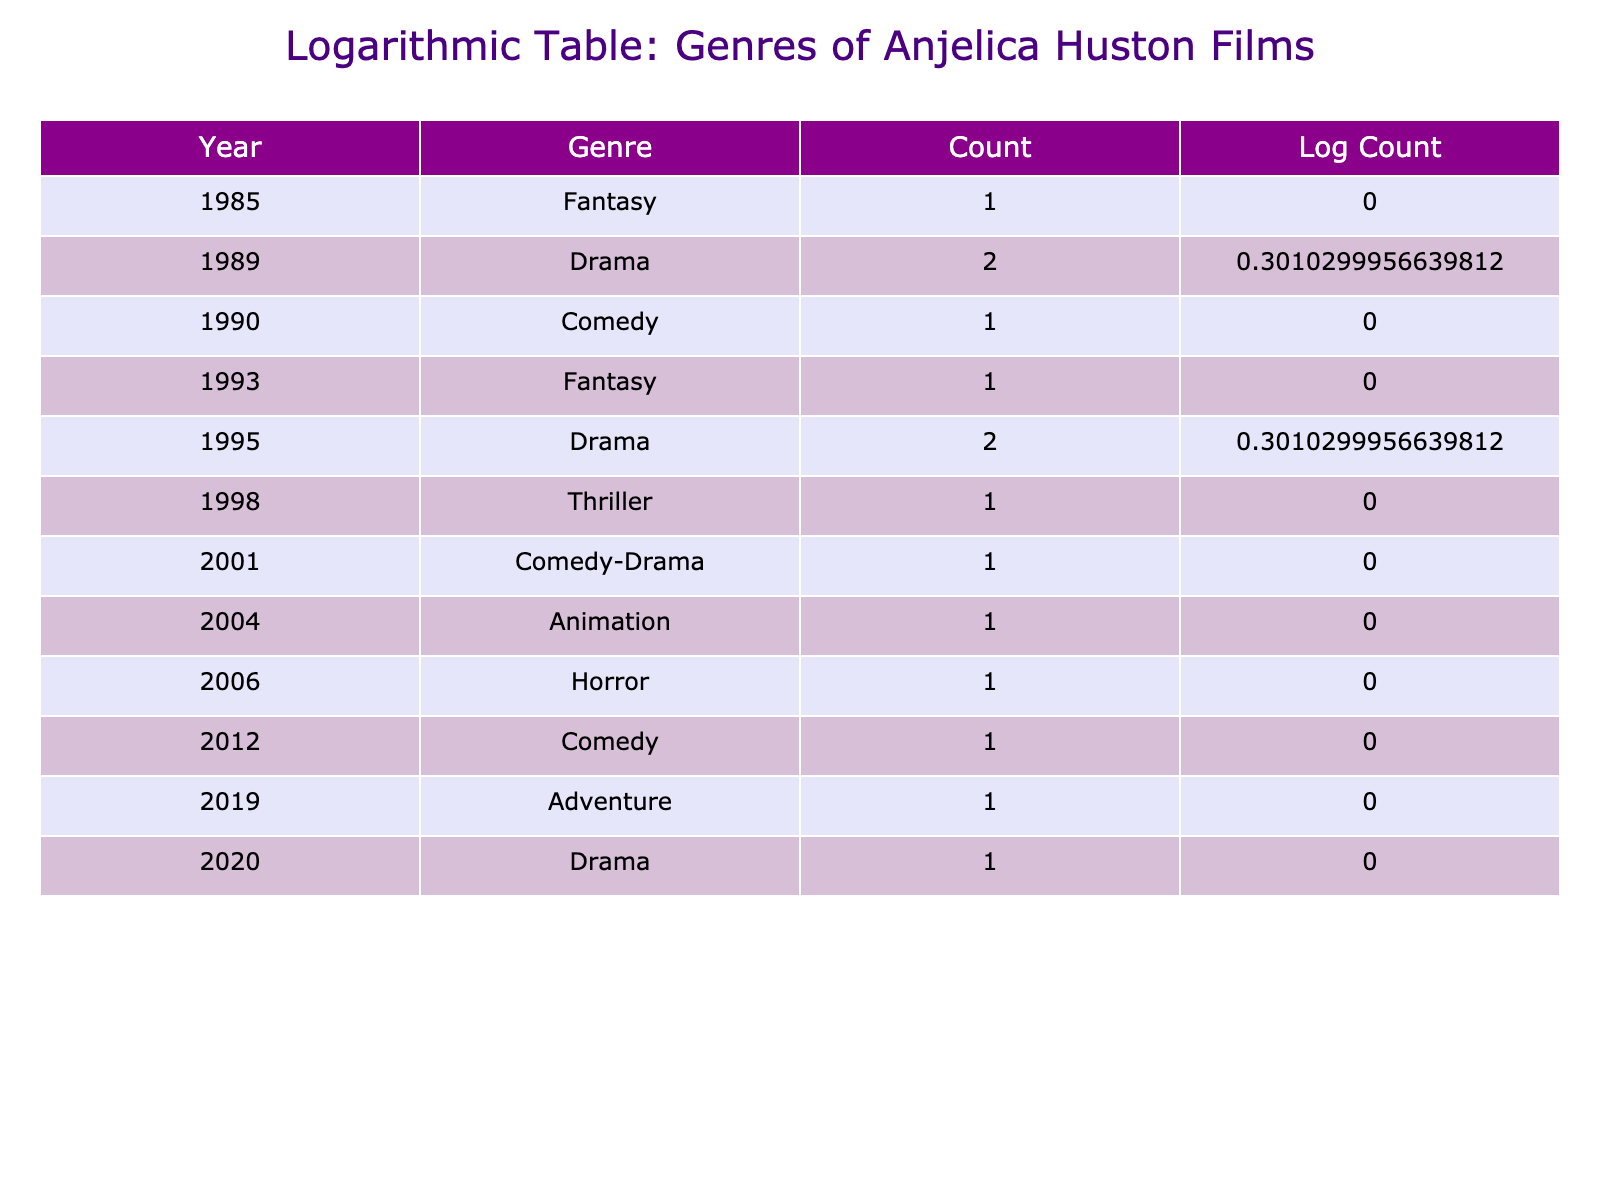What genres are represented in Anjelica Huston's films? The table shows various genres of films starring Anjelica Huston across different years, including Fantasy, Drama, Comedy, Thriller, Comedy-Drama, Animation, Horror, and Adventure. Each genre has at least one count representing its occurrence.
Answer: Fantasy, Drama, Comedy, Thriller, Comedy-Drama, Animation, Horror, Adventure In which year did Anjelica Huston star in the most films? By looking at the "Count" column in the table, I see that the years 1989, 1995, and 2004 have the highest count of 2 films each. Thus, these years tied for the most films.
Answer: 1989, 1995, 2004 What is the total number of films starring Anjelica Huston listed in the table? The counts of films across all years are: 1, 2, 1, 1, 2, 1, 1, 1, 1, 1. Adding them together gives a total of 12 films.
Answer: 12 Is there a year in which Anjelica Huston starred in only comedy films? Checking the table, I find that the only instance of a comedy film occurs in 1990, 2001, and 2012. None of the years have exclusively comedy films, so the answer is no.
Answer: No What is the average number of films per genre featured in the table? To calculate the average, we first note there are 9 genres represented (from the table), and the total count of films is 12. The average is calculated by dividing 12 by 9, which results in approximately 1.33 films per genre.
Answer: 1.33 How many genres have one film represented in the table? From the table, genres with one film are: Fantasy (1985), Comedy (1990), Thriller (1998), Comedy-Drama (2001), Animation (2004), Horror (2006), Adventure (2019), and Drama (2020). This counts up to 8 genres.
Answer: 8 In which genre did Anjelica Huston not perform in the 2000s? Checking the years from 2000 to 2009, we see genres like Horror (2006) and Animation (2004) are included. However, the Drama genre has not been represented between 2000-2009, especially with no films in 2003. Thus, Drama is the genre not performed in the 2000s.
Answer: Drama How has the trend of film genres starring Anjelica Huston changed over the years? By analyzing the table data chronologically, we see a mix of genres across the years, with occasional peaks in Drama and Comedy. The shift from Fantasy and Drama in earlier years to Comedy and Adventure in latter years highlights a transition in genre representation throughout her career.
Answer: Mixed representation, transition from Fantasy/Drama to Comedy/Adventure 